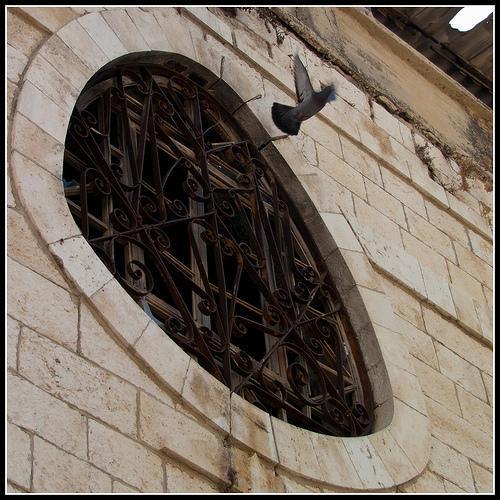How many birds are shown?
Give a very brief answer. 1. 